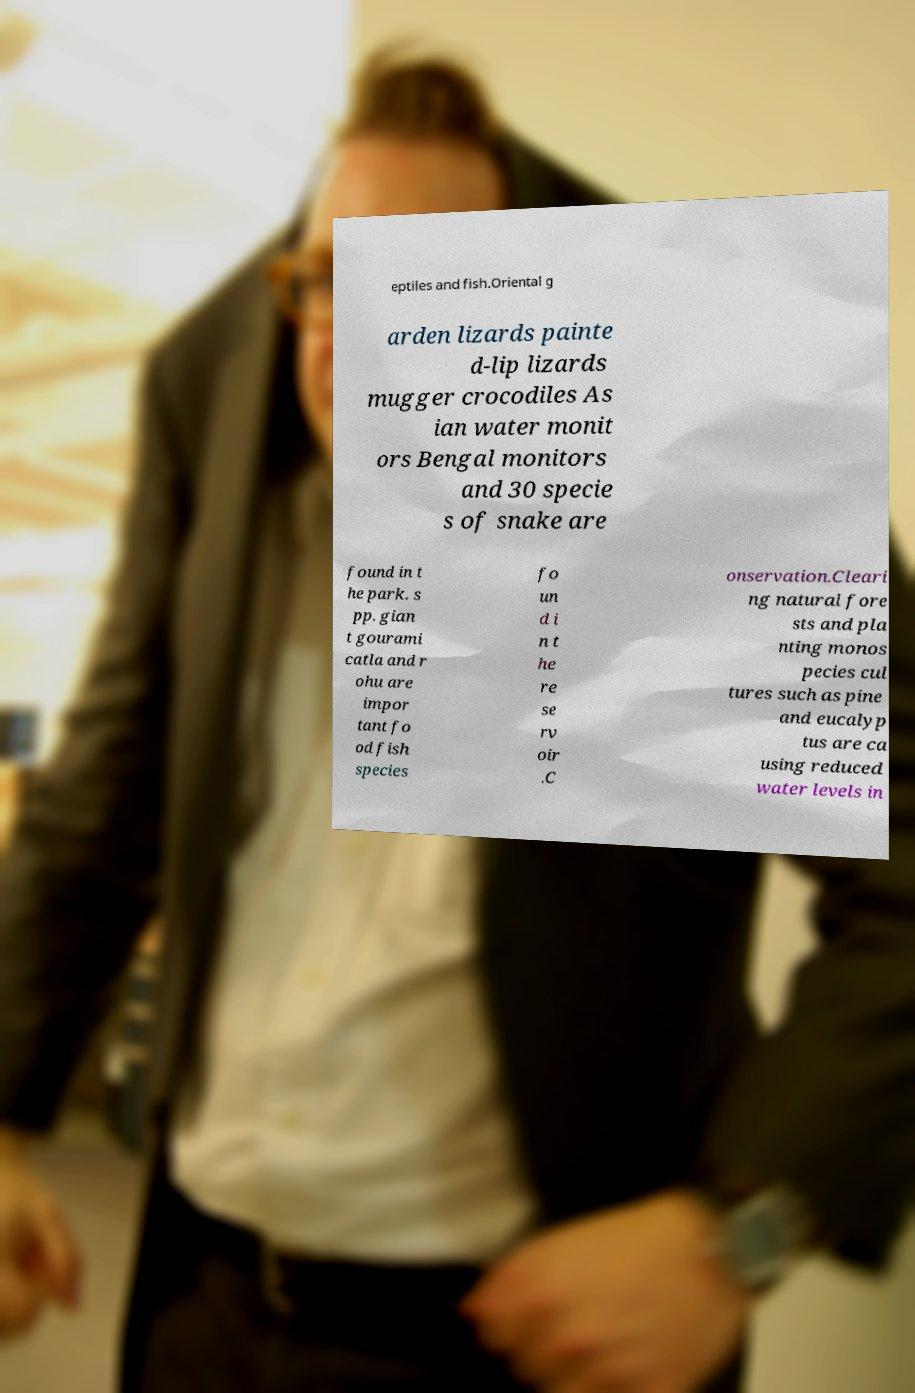For documentation purposes, I need the text within this image transcribed. Could you provide that? eptiles and fish.Oriental g arden lizards painte d-lip lizards mugger crocodiles As ian water monit ors Bengal monitors and 30 specie s of snake are found in t he park. s pp. gian t gourami catla and r ohu are impor tant fo od fish species fo un d i n t he re se rv oir .C onservation.Cleari ng natural fore sts and pla nting monos pecies cul tures such as pine and eucalyp tus are ca using reduced water levels in 